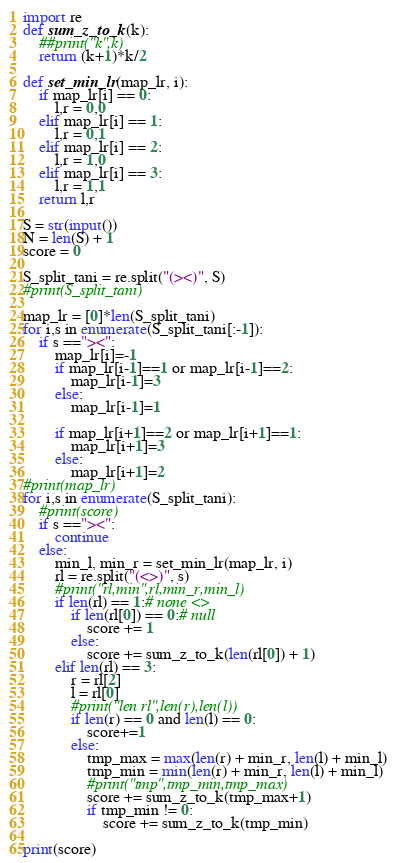Convert code to text. <code><loc_0><loc_0><loc_500><loc_500><_Python_>import re
def sum_z_to_k(k):
    ##print("k",k)
    return (k+1)*k/2

def set_min_lr(map_lr, i):
    if map_lr[i] == 0:
        l,r = 0,0
    elif map_lr[i] == 1:
        l,r = 0,1
    elif map_lr[i] == 2:
        l,r = 1,0
    elif map_lr[i] == 3:
        l,r = 1,1
    return l,r

S = str(input())
N = len(S) + 1
score = 0

S_split_tani = re.split("(><)", S)
#print(S_split_tani)

map_lr = [0]*len(S_split_tani)
for i,s in enumerate(S_split_tani[:-1]):
    if s =="><":
        map_lr[i]=-1
        if map_lr[i-1]==1 or map_lr[i-1]==2:
            map_lr[i-1]=3
        else:
	        map_lr[i-1]=1

        if map_lr[i+1]==2 or map_lr[i+1]==1:
            map_lr[i+1]=3
        else:
    	    map_lr[i+1]=2
#print(map_lr)
for i,s in enumerate(S_split_tani):
    #print(score)
    if s =="><":
        continue
    else:
        min_l, min_r = set_min_lr(map_lr, i)
        rl = re.split("(<>)", s)
        #print("rl,min",rl,min_r,min_l)
        if len(rl) == 1:# none <>
            if len(rl[0]) == 0:# null
                score += 1
            else:
                score += sum_z_to_k(len(rl[0]) + 1)
        elif len(rl) == 3:
            r = rl[2]
            l = rl[0]
            #print("len rl",len(r),len(l))
            if len(r) == 0 and len(l) == 0:
                score+=1
            else:
                tmp_max = max(len(r) + min_r, len(l) + min_l)
                tmp_min = min(len(r) + min_r, len(l) + min_l)
                #print("tmp",tmp_min,tmp_max)
                score += sum_z_to_k(tmp_max+1)
                if tmp_min != 0:
                    score += sum_z_to_k(tmp_min)

print(score)</code> 